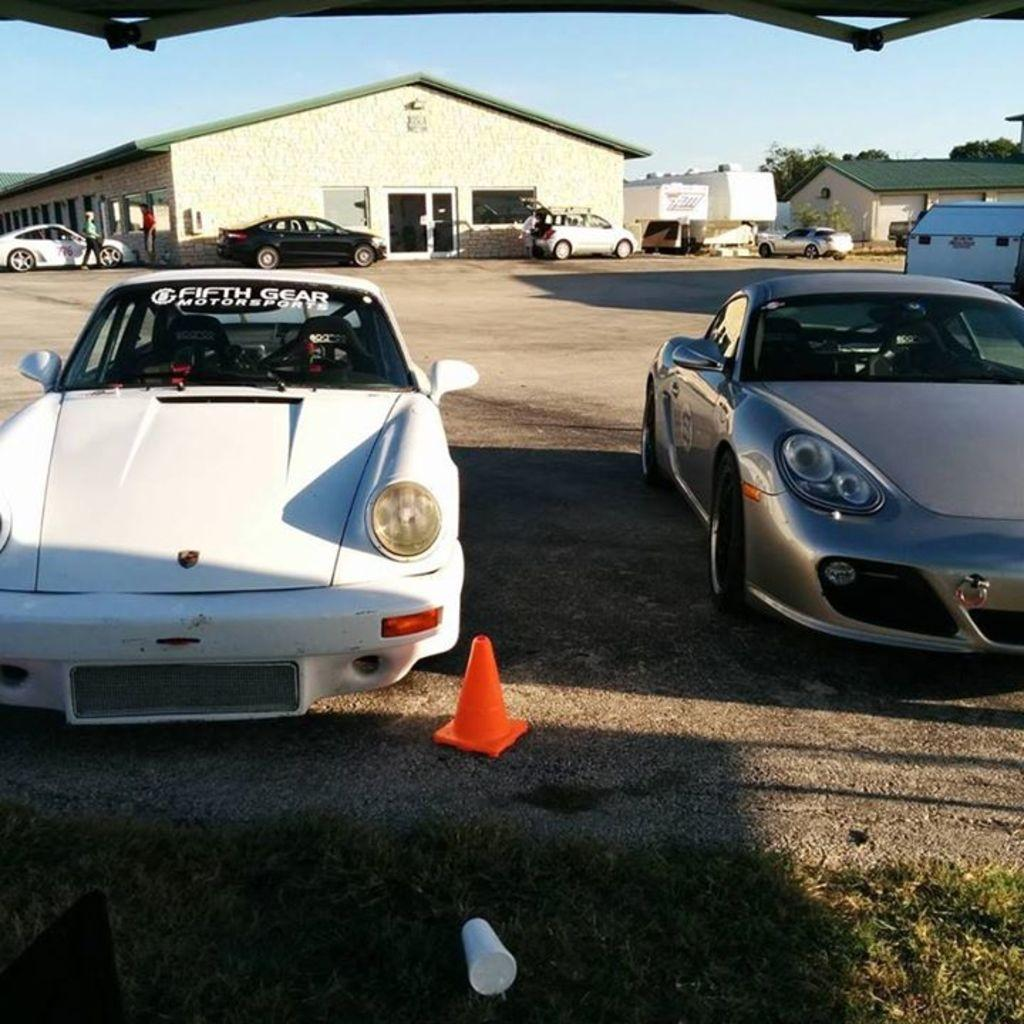What can be seen on the road in the image? There are cars on the road in the image. Who or what is present in the image besides the cars? There are people in the image. What object can be seen at the bottom of the image? There is a traffic cone and a glass at the bottom of the image. What type of natural environment is visible in the image? There is grass visible in the image. What is visible in the background of the image? There is sky visible in the background of the image. Can you tell me what type of powder the writer is using in the image? There is no writer or powder present in the image. Is the tiger interacting with the traffic cone in the image? There is no tiger present in the image. 